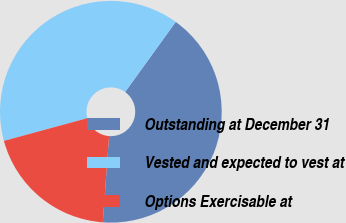Convert chart to OTSL. <chart><loc_0><loc_0><loc_500><loc_500><pie_chart><fcel>Outstanding at December 31<fcel>Vested and expected to vest at<fcel>Options Exercisable at<nl><fcel>41.21%<fcel>39.19%<fcel>19.61%<nl></chart> 